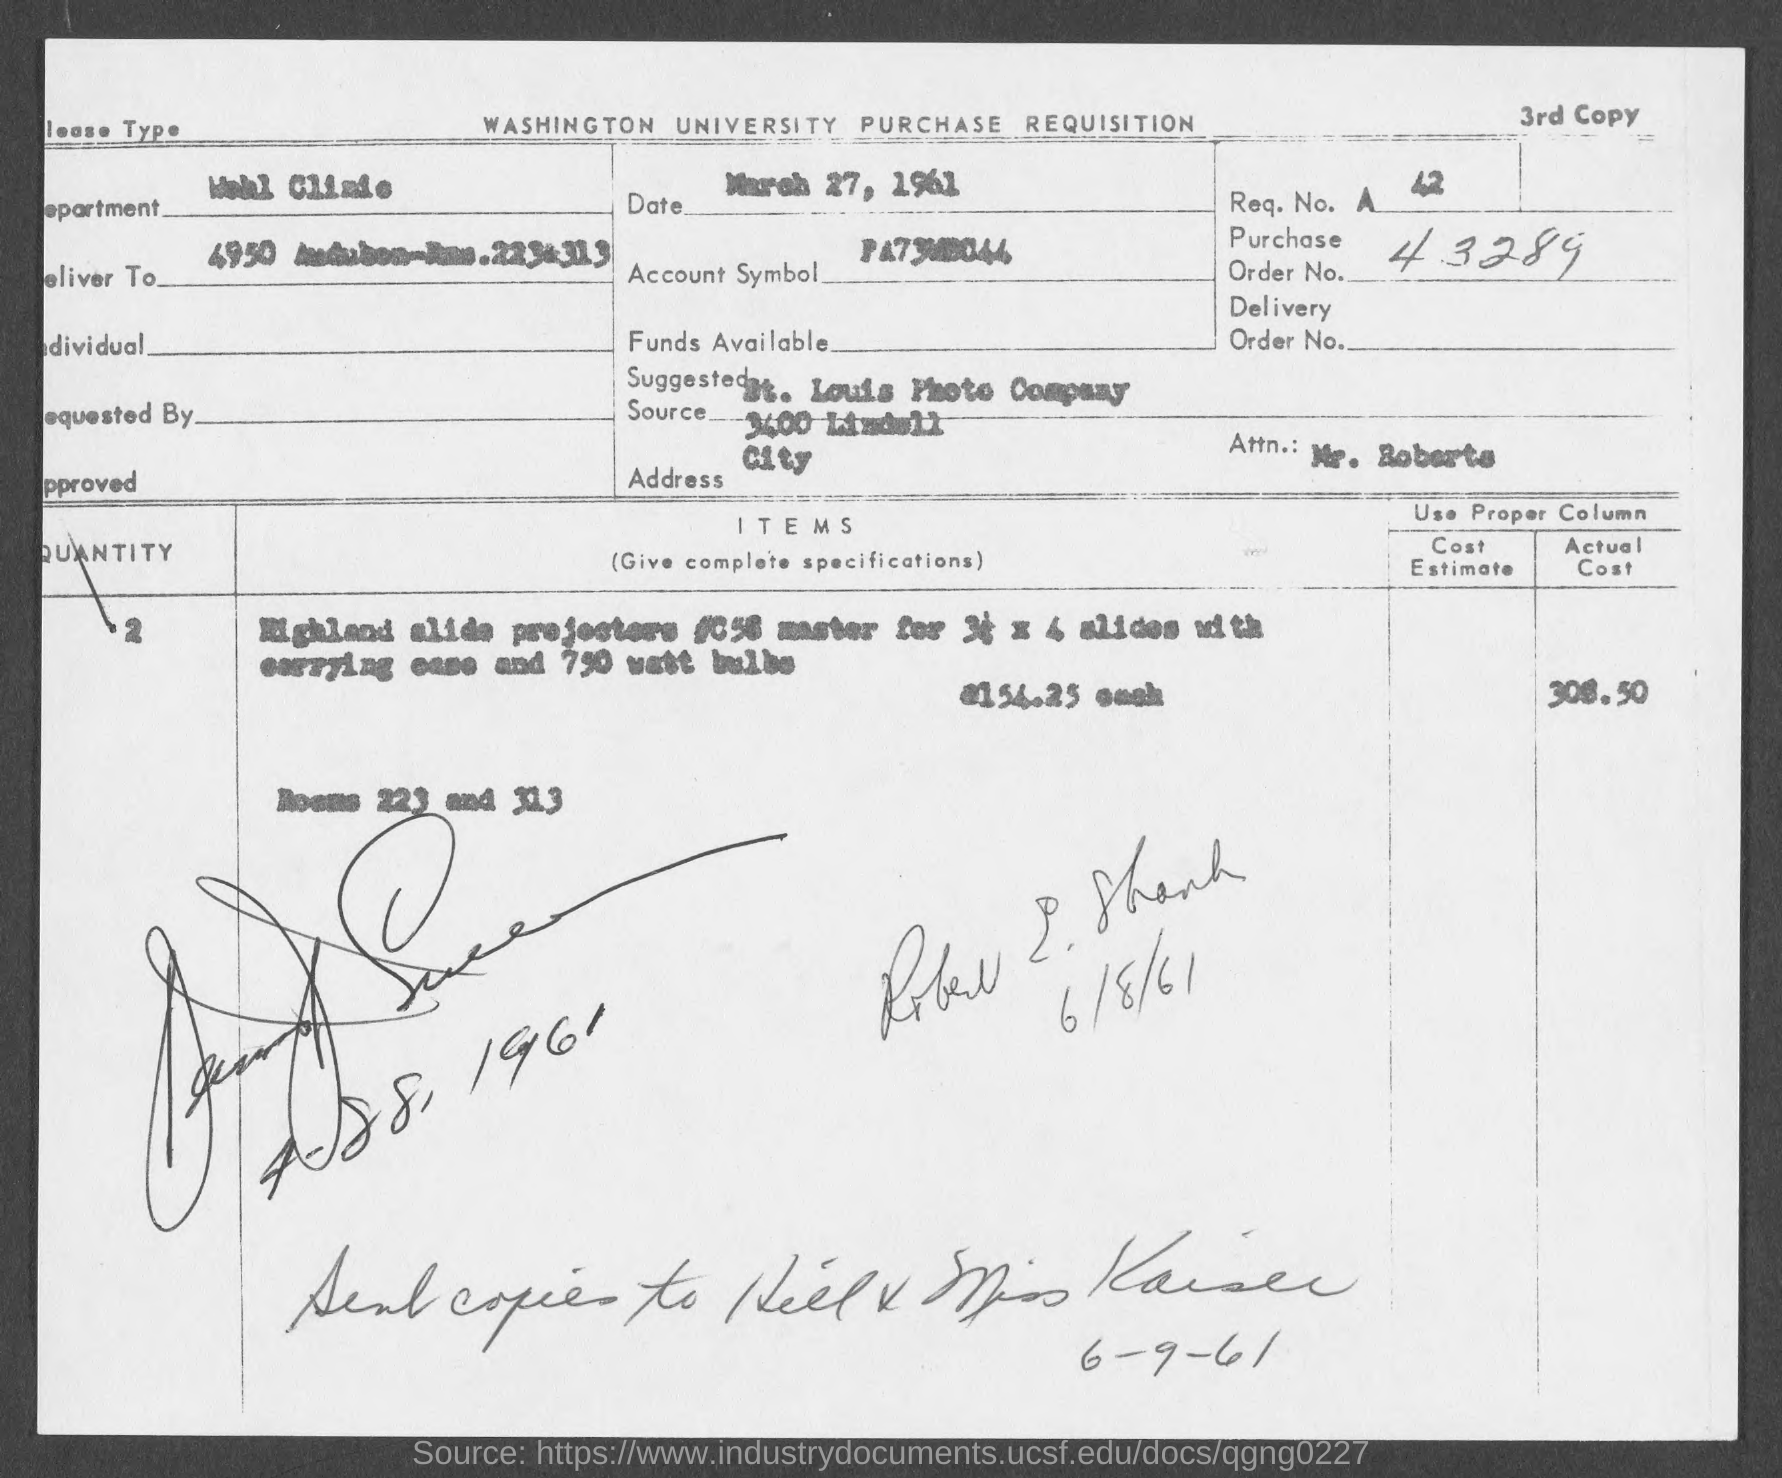What is the req. no. mentioned in the given page ?
Your answer should be very brief. 42. What is the purchase order no. mentioned in the given page ?
Make the answer very short. 43289. What is the name of the department mentioned in the given form ?
Offer a very short reply. Wohl clinic. What is the date mentioned in the given page ?
Your answer should be compact. March 27, 1961. What is the actual cost of highland alide projectors mentioned in the given form ?
Your response must be concise. 308.50. What is the quantity of highland alide projectors mentioned in the given form ?
Keep it short and to the point. 2. 